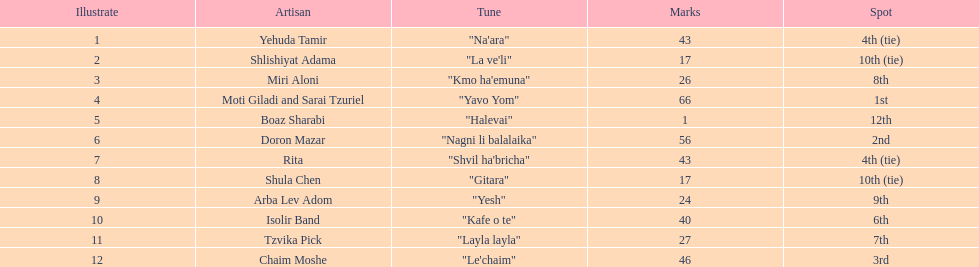What is the name of the first song listed on this chart? "Na'ara". 